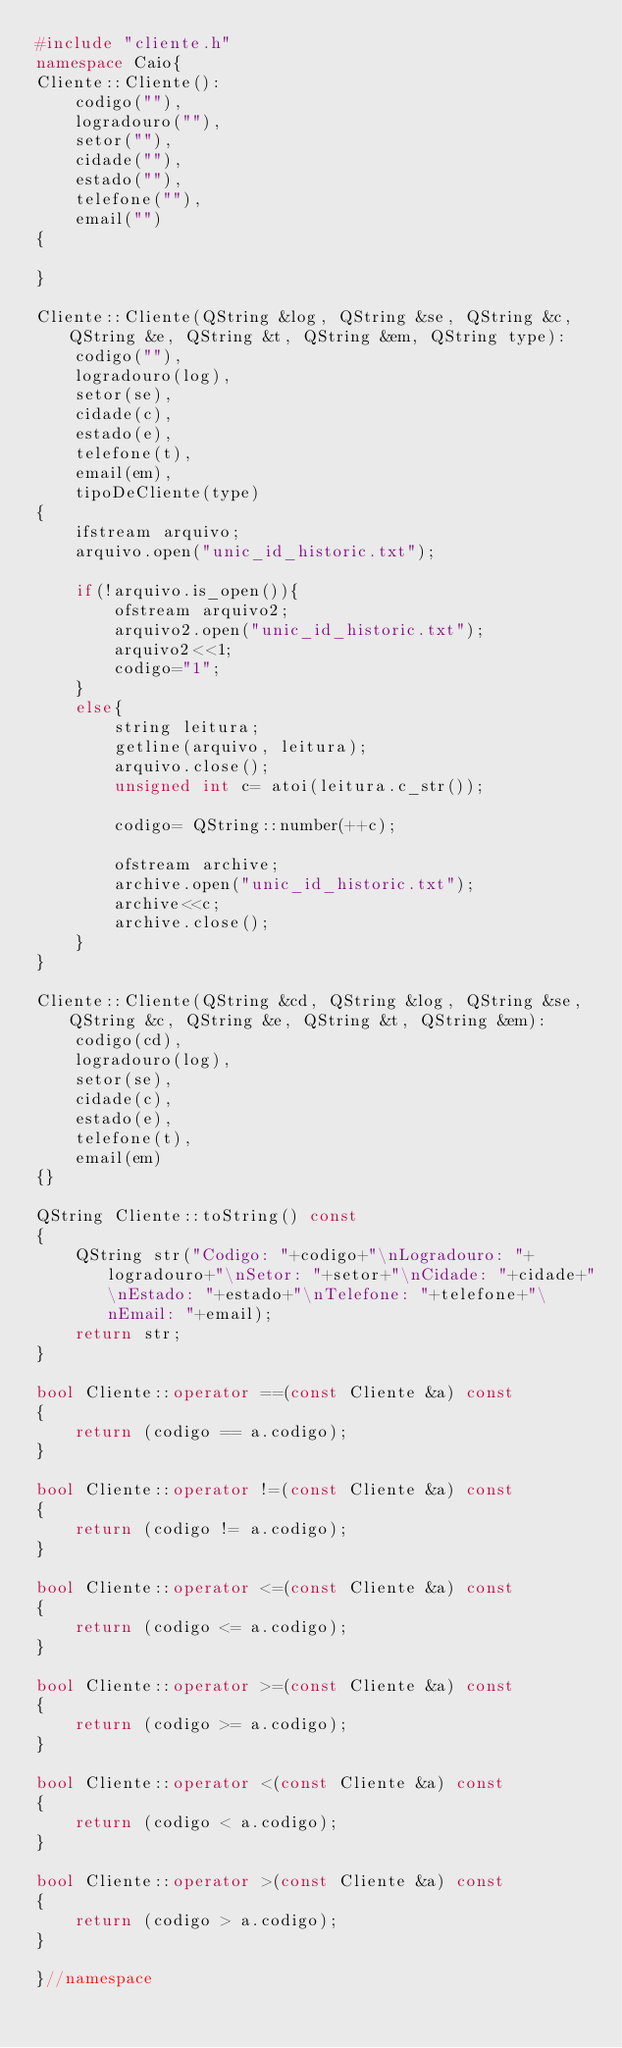Convert code to text. <code><loc_0><loc_0><loc_500><loc_500><_C++_>#include "cliente.h"
namespace Caio{
Cliente::Cliente():
    codigo(""),
    logradouro(""),
    setor(""),
    cidade(""),
    estado(""),
    telefone(""),
    email("")
{

}

Cliente::Cliente(QString &log, QString &se, QString &c, QString &e, QString &t, QString &em, QString type):
    codigo(""),
    logradouro(log),
    setor(se),
    cidade(c),
    estado(e),
    telefone(t),
    email(em),
    tipoDeCliente(type)
{
    ifstream arquivo;
    arquivo.open("unic_id_historic.txt");

    if(!arquivo.is_open()){
        ofstream arquivo2;
        arquivo2.open("unic_id_historic.txt");
        arquivo2<<1;
        codigo="1";
    }
    else{
        string leitura;
        getline(arquivo, leitura);
        arquivo.close();
        unsigned int c= atoi(leitura.c_str());

        codigo= QString::number(++c);

        ofstream archive;
        archive.open("unic_id_historic.txt");
        archive<<c;
        archive.close();
    }
}

Cliente::Cliente(QString &cd, QString &log, QString &se, QString &c, QString &e, QString &t, QString &em):
    codigo(cd),
    logradouro(log),
    setor(se),
    cidade(c),
    estado(e),
    telefone(t),
    email(em)
{}

QString Cliente::toString() const
{
    QString str("Codigo: "+codigo+"\nLogradouro: "+logradouro+"\nSetor: "+setor+"\nCidade: "+cidade+"\nEstado: "+estado+"\nTelefone: "+telefone+"\nEmail: "+email);
    return str;
}

bool Cliente::operator ==(const Cliente &a) const
{
    return (codigo == a.codigo);
}

bool Cliente::operator !=(const Cliente &a) const
{
    return (codigo != a.codigo);
}

bool Cliente::operator <=(const Cliente &a) const
{
    return (codigo <= a.codigo);
}

bool Cliente::operator >=(const Cliente &a) const
{
    return (codigo >= a.codigo);
}

bool Cliente::operator <(const Cliente &a) const
{
    return (codigo < a.codigo);
}

bool Cliente::operator >(const Cliente &a) const
{
    return (codigo > a.codigo);
}

}//namespace
</code> 